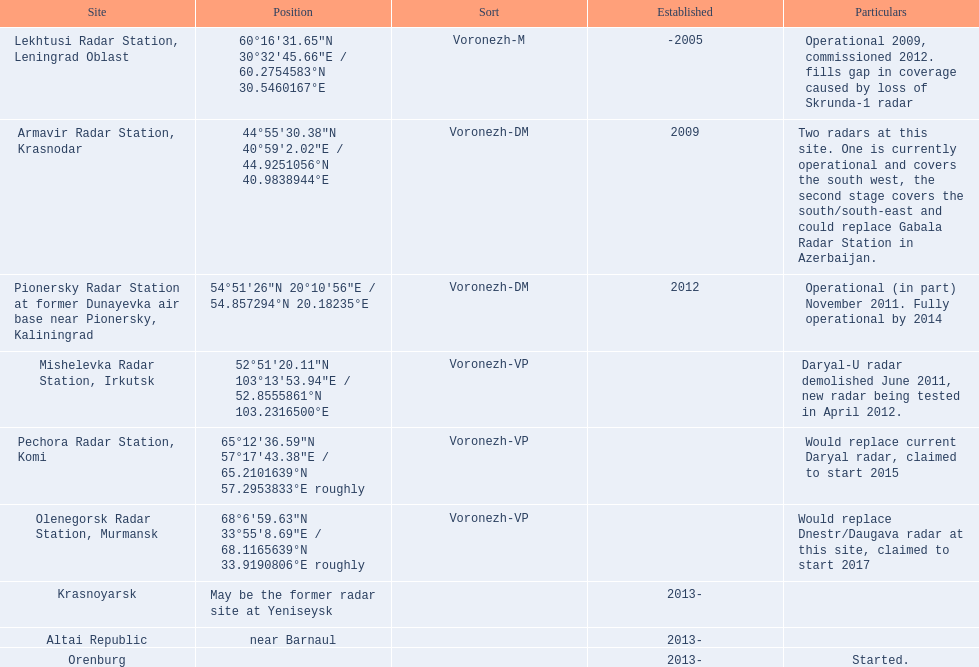What are the list of radar locations? Lekhtusi Radar Station, Leningrad Oblast, Armavir Radar Station, Krasnodar, Pionersky Radar Station at former Dunayevka air base near Pionersky, Kaliningrad, Mishelevka Radar Station, Irkutsk, Pechora Radar Station, Komi, Olenegorsk Radar Station, Murmansk, Krasnoyarsk, Altai Republic, Orenburg. Which of these are claimed to start in 2015? Pechora Radar Station, Komi. 